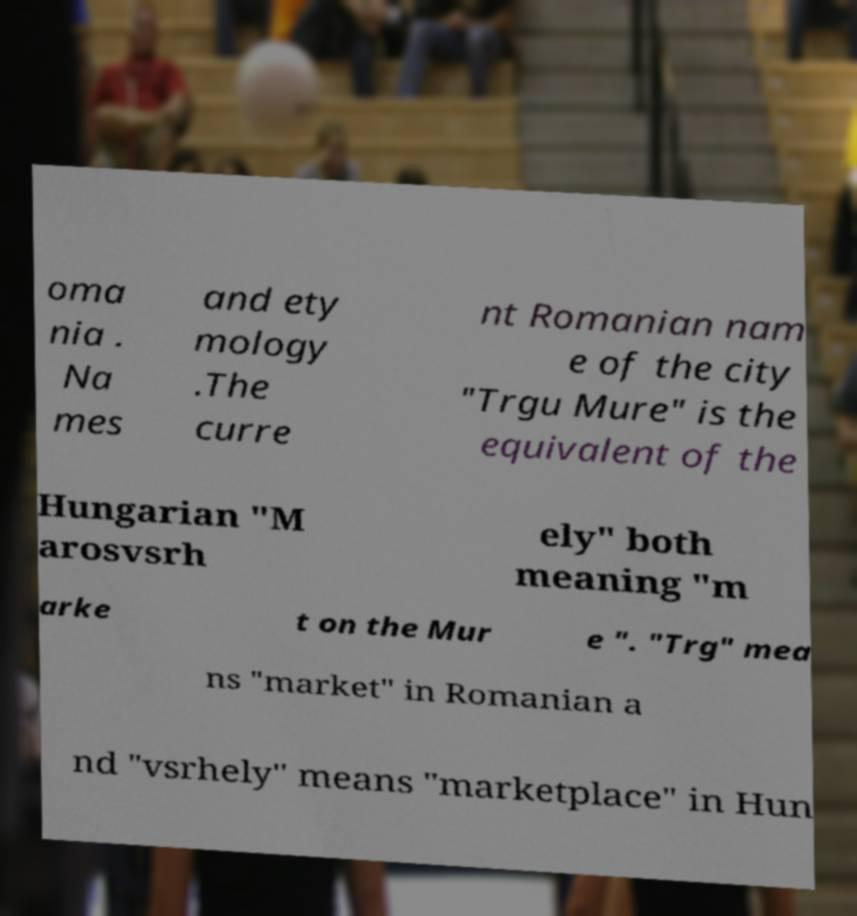Please identify and transcribe the text found in this image. oma nia . Na mes and ety mology .The curre nt Romanian nam e of the city "Trgu Mure" is the equivalent of the Hungarian "M arosvsrh ely" both meaning "m arke t on the Mur e ". "Trg" mea ns "market" in Romanian a nd "vsrhely" means "marketplace" in Hun 